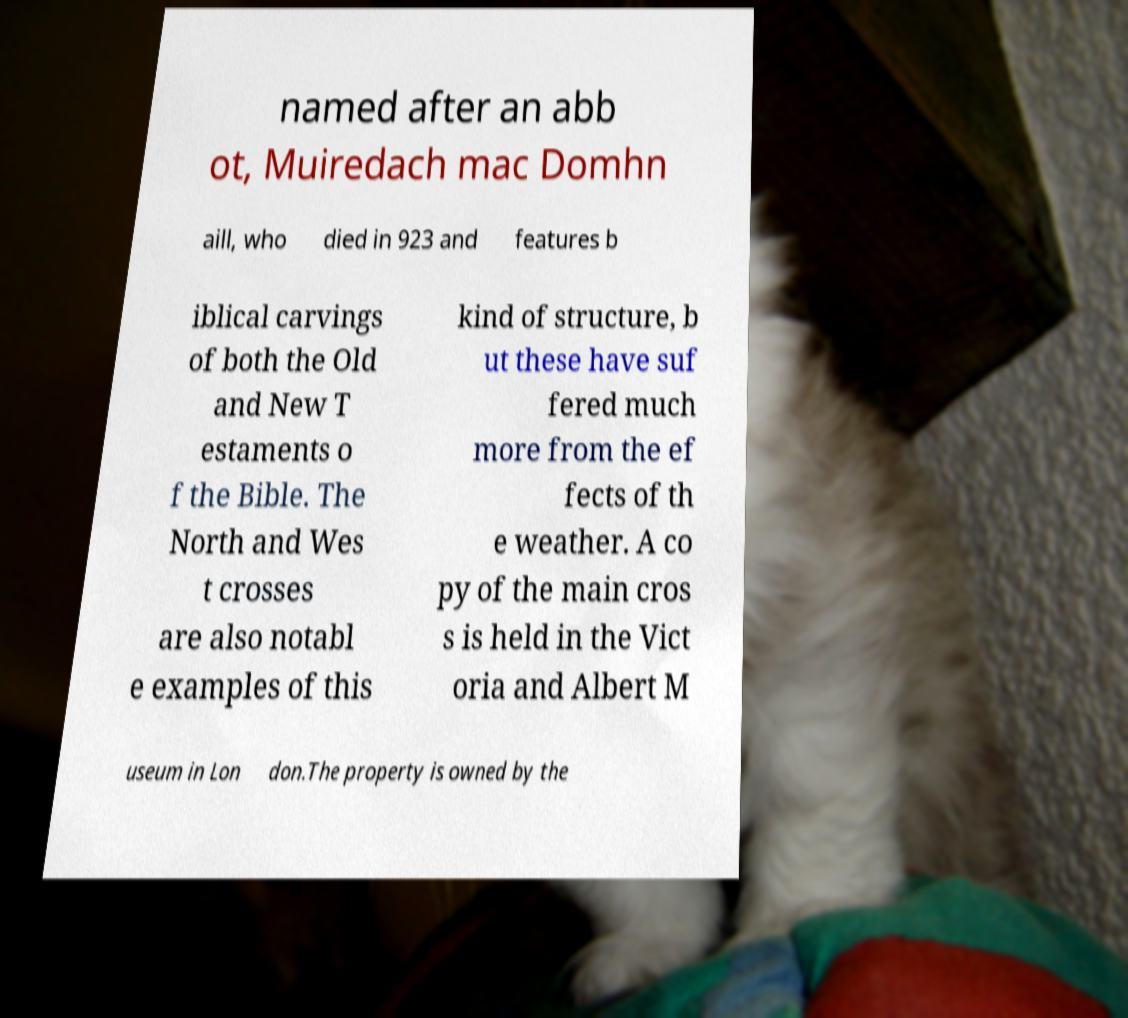For documentation purposes, I need the text within this image transcribed. Could you provide that? named after an abb ot, Muiredach mac Domhn aill, who died in 923 and features b iblical carvings of both the Old and New T estaments o f the Bible. The North and Wes t crosses are also notabl e examples of this kind of structure, b ut these have suf fered much more from the ef fects of th e weather. A co py of the main cros s is held in the Vict oria and Albert M useum in Lon don.The property is owned by the 